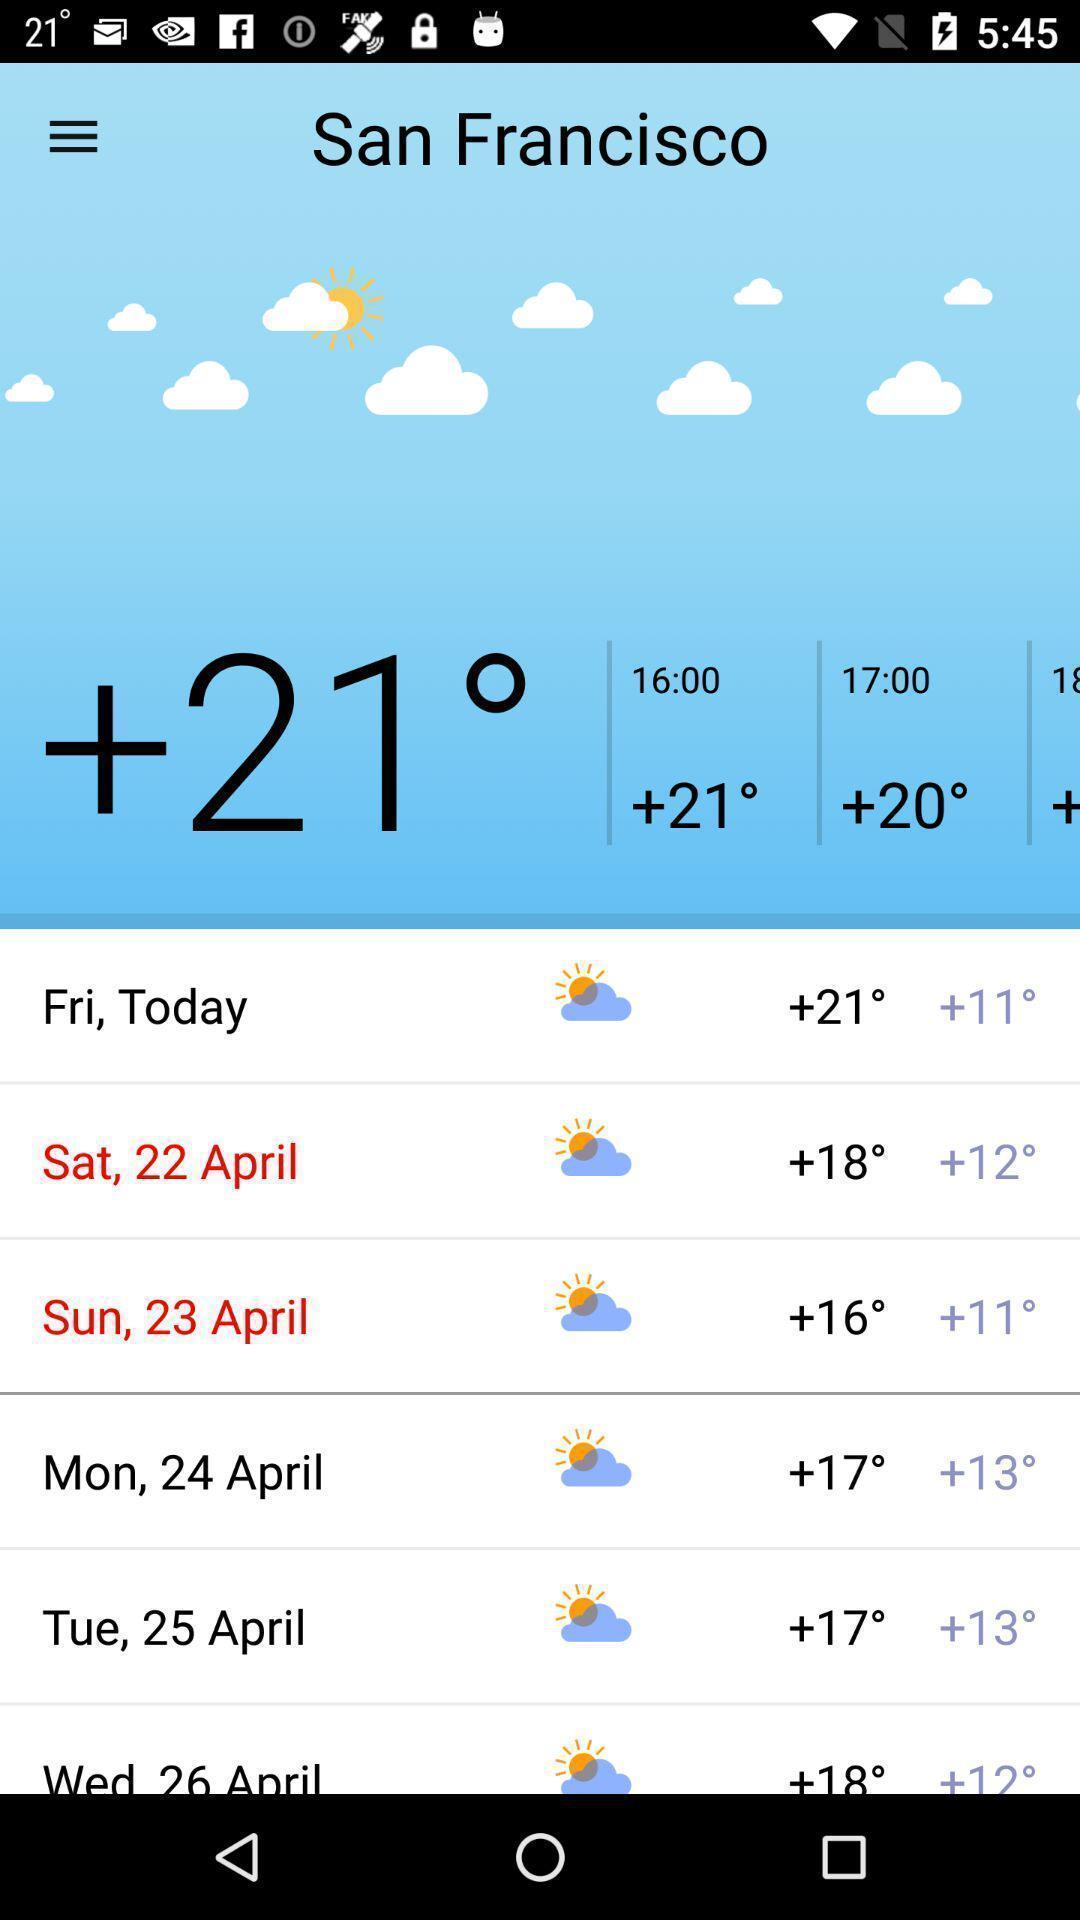Describe the content in this image. Screen page displaying various details in weather application. 